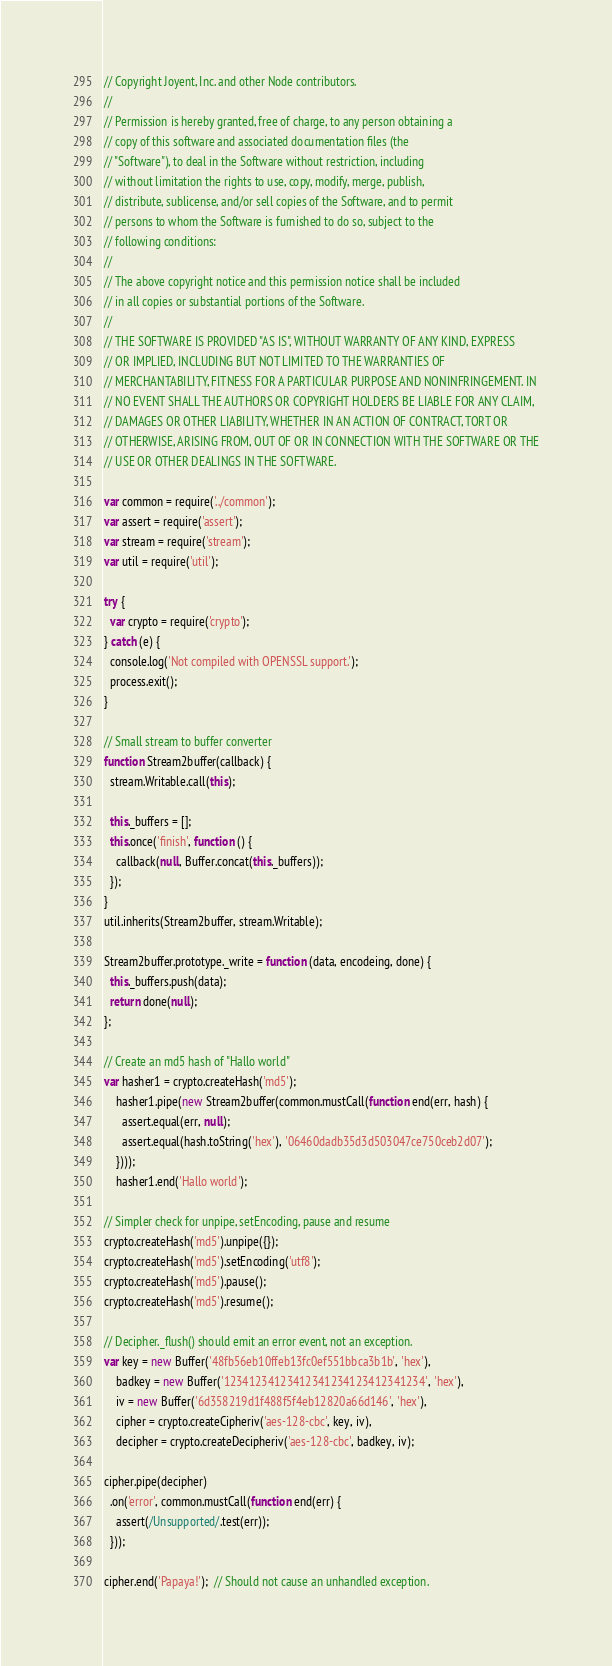Convert code to text. <code><loc_0><loc_0><loc_500><loc_500><_JavaScript_>// Copyright Joyent, Inc. and other Node contributors.
//
// Permission is hereby granted, free of charge, to any person obtaining a
// copy of this software and associated documentation files (the
// "Software"), to deal in the Software without restriction, including
// without limitation the rights to use, copy, modify, merge, publish,
// distribute, sublicense, and/or sell copies of the Software, and to permit
// persons to whom the Software is furnished to do so, subject to the
// following conditions:
//
// The above copyright notice and this permission notice shall be included
// in all copies or substantial portions of the Software.
//
// THE SOFTWARE IS PROVIDED "AS IS", WITHOUT WARRANTY OF ANY KIND, EXPRESS
// OR IMPLIED, INCLUDING BUT NOT LIMITED TO THE WARRANTIES OF
// MERCHANTABILITY, FITNESS FOR A PARTICULAR PURPOSE AND NONINFRINGEMENT. IN
// NO EVENT SHALL THE AUTHORS OR COPYRIGHT HOLDERS BE LIABLE FOR ANY CLAIM,
// DAMAGES OR OTHER LIABILITY, WHETHER IN AN ACTION OF CONTRACT, TORT OR
// OTHERWISE, ARISING FROM, OUT OF OR IN CONNECTION WITH THE SOFTWARE OR THE
// USE OR OTHER DEALINGS IN THE SOFTWARE.

var common = require('../common');
var assert = require('assert');
var stream = require('stream');
var util = require('util');

try {
  var crypto = require('crypto');
} catch (e) {
  console.log('Not compiled with OPENSSL support.');
  process.exit();
}

// Small stream to buffer converter
function Stream2buffer(callback) {
  stream.Writable.call(this);

  this._buffers = [];
  this.once('finish', function () {
    callback(null, Buffer.concat(this._buffers));
  });
}
util.inherits(Stream2buffer, stream.Writable);

Stream2buffer.prototype._write = function (data, encodeing, done) {
  this._buffers.push(data);
  return done(null);
};

// Create an md5 hash of "Hallo world"
var hasher1 = crypto.createHash('md5');
    hasher1.pipe(new Stream2buffer(common.mustCall(function end(err, hash) {
      assert.equal(err, null);
      assert.equal(hash.toString('hex'), '06460dadb35d3d503047ce750ceb2d07');
    })));
    hasher1.end('Hallo world');

// Simpler check for unpipe, setEncoding, pause and resume
crypto.createHash('md5').unpipe({});
crypto.createHash('md5').setEncoding('utf8');
crypto.createHash('md5').pause();
crypto.createHash('md5').resume();

// Decipher._flush() should emit an error event, not an exception.
var key = new Buffer('48fb56eb10ffeb13fc0ef551bbca3b1b', 'hex'),
    badkey = new Buffer('12341234123412341234123412341234', 'hex'),
    iv = new Buffer('6d358219d1f488f5f4eb12820a66d146', 'hex'),
    cipher = crypto.createCipheriv('aes-128-cbc', key, iv),
    decipher = crypto.createDecipheriv('aes-128-cbc', badkey, iv);

cipher.pipe(decipher)
  .on('error', common.mustCall(function end(err) {
    assert(/Unsupported/.test(err));
  }));

cipher.end('Papaya!');  // Should not cause an unhandled exception.
</code> 